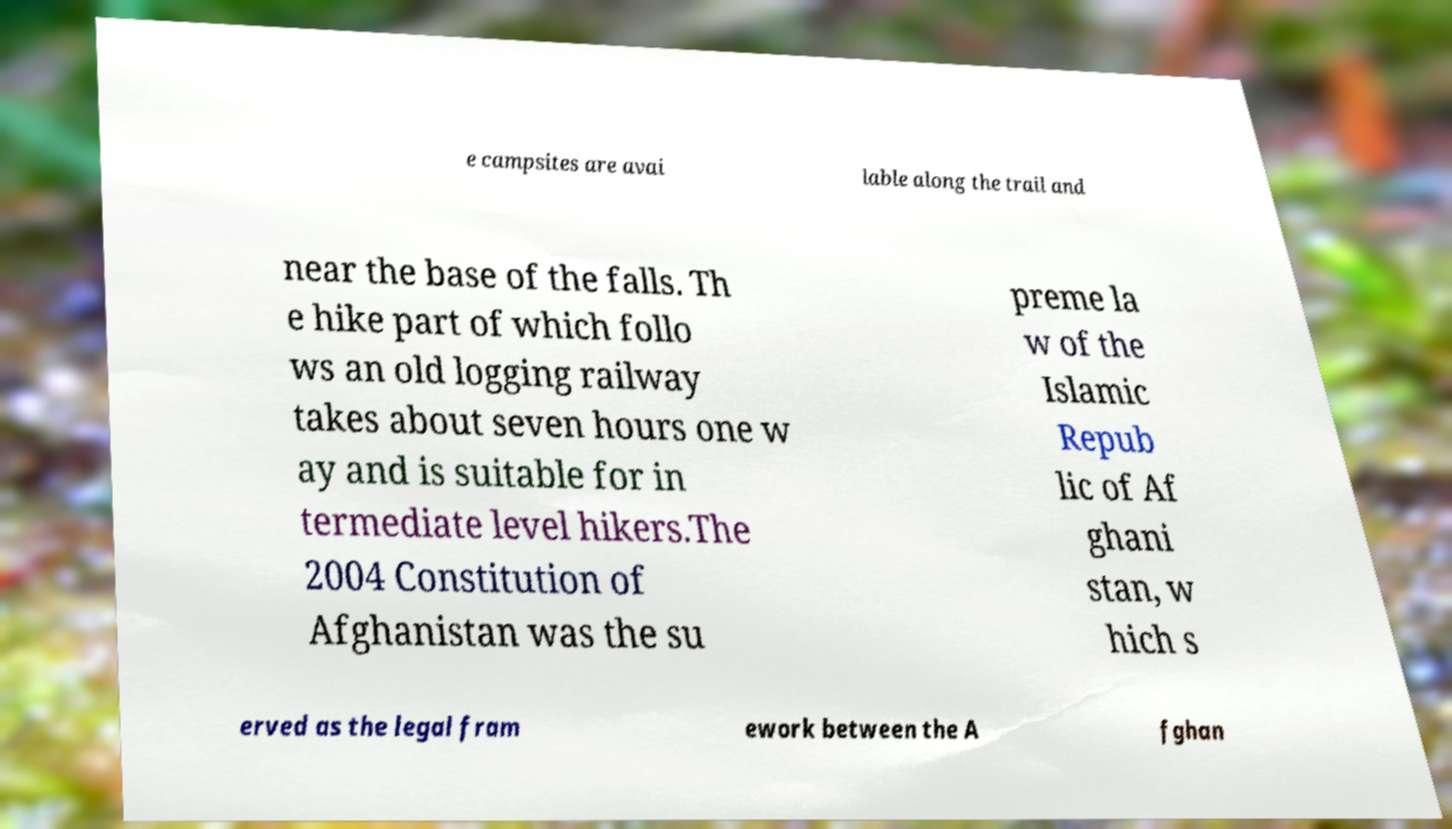Can you read and provide the text displayed in the image?This photo seems to have some interesting text. Can you extract and type it out for me? e campsites are avai lable along the trail and near the base of the falls. Th e hike part of which follo ws an old logging railway takes about seven hours one w ay and is suitable for in termediate level hikers.The 2004 Constitution of Afghanistan was the su preme la w of the Islamic Repub lic of Af ghani stan, w hich s erved as the legal fram ework between the A fghan 